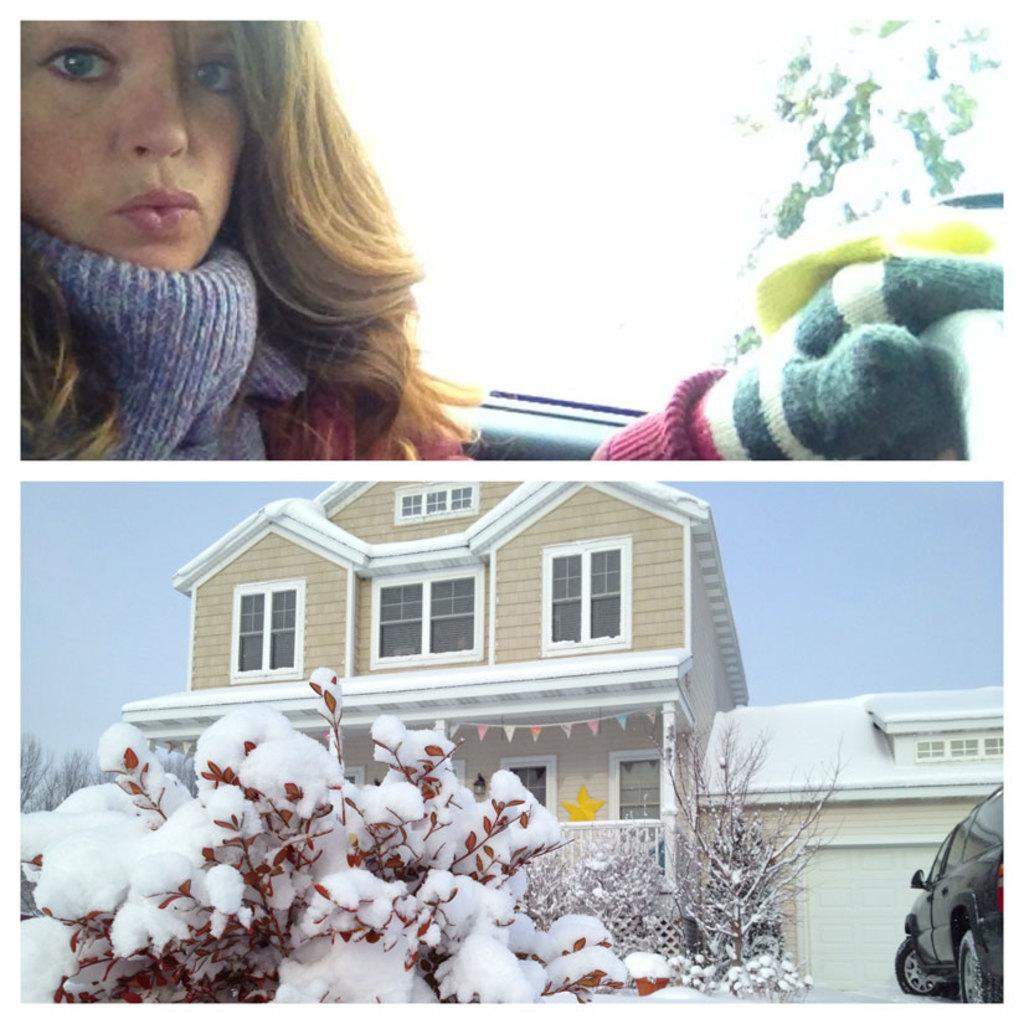What type of artwork is the image? The image is a collage. What type of structure can be seen in the collage? There is a house in the collage. What type of vegetation is present in the collage? There are trees in the collage. What weather condition is depicted in the collage? There is snow in the collage. What type of vehicle is parked near the house in the collage? There is a car in a parking space near the house in the collage. Whose face is visible in the collage? A person's face is visible in the collage. How does the milk heat up in the image? There is no milk present in the image, so it cannot be heated up. 